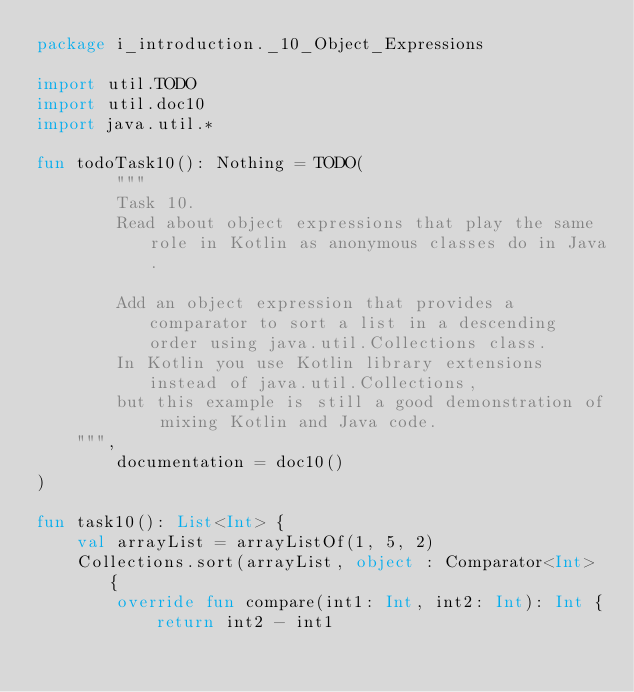Convert code to text. <code><loc_0><loc_0><loc_500><loc_500><_Kotlin_>package i_introduction._10_Object_Expressions

import util.TODO
import util.doc10
import java.util.*

fun todoTask10(): Nothing = TODO(
        """
        Task 10.
        Read about object expressions that play the same role in Kotlin as anonymous classes do in Java.

        Add an object expression that provides a comparator to sort a list in a descending order using java.util.Collections class.
        In Kotlin you use Kotlin library extensions instead of java.util.Collections,
        but this example is still a good demonstration of mixing Kotlin and Java code.
    """,
        documentation = doc10()
)

fun task10(): List<Int> {
    val arrayList = arrayListOf(1, 5, 2)
    Collections.sort(arrayList, object : Comparator<Int> {
        override fun compare(int1: Int, int2: Int): Int {
            return int2 - int1</code> 